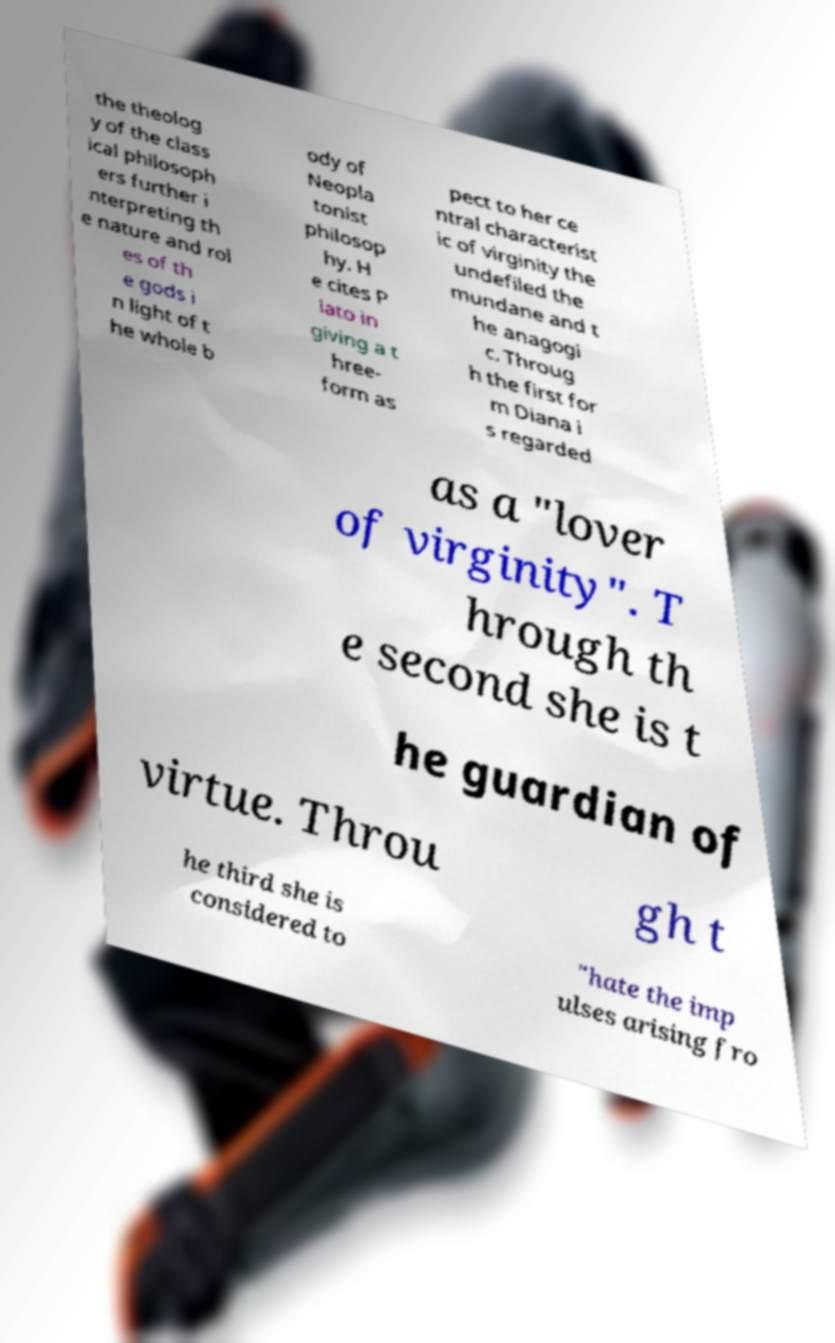There's text embedded in this image that I need extracted. Can you transcribe it verbatim? the theolog y of the class ical philosoph ers further i nterpreting th e nature and rol es of th e gods i n light of t he whole b ody of Neopla tonist philosop hy. H e cites P lato in giving a t hree- form as pect to her ce ntral characterist ic of virginity the undefiled the mundane and t he anagogi c. Throug h the first for m Diana i s regarded as a "lover of virginity". T hrough th e second she is t he guardian of virtue. Throu gh t he third she is considered to "hate the imp ulses arising fro 